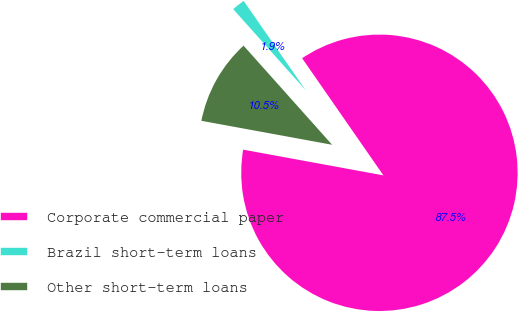<chart> <loc_0><loc_0><loc_500><loc_500><pie_chart><fcel>Corporate commercial paper<fcel>Brazil short-term loans<fcel>Other short-term loans<nl><fcel>87.55%<fcel>1.95%<fcel>10.51%<nl></chart> 